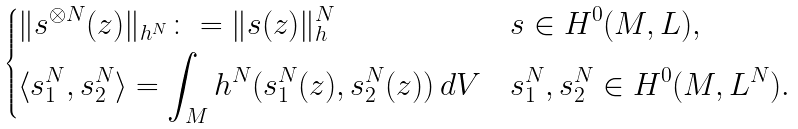<formula> <loc_0><loc_0><loc_500><loc_500>\begin{dcases} \| s ^ { \otimes N } ( z ) \| _ { h ^ { N } } \colon = \| s ( z ) \| _ { h } ^ { N } & s \in H ^ { 0 } ( M , L ) , \\ \langle s _ { 1 } ^ { N } , s _ { 2 } ^ { N } \rangle = \int _ { M } h ^ { N } ( s _ { 1 } ^ { N } ( z ) , s _ { 2 } ^ { N } ( z ) ) \, d V & s _ { 1 } ^ { N } , s _ { 2 } ^ { N } \in H ^ { 0 } ( M , L ^ { N } ) . \end{dcases}</formula> 